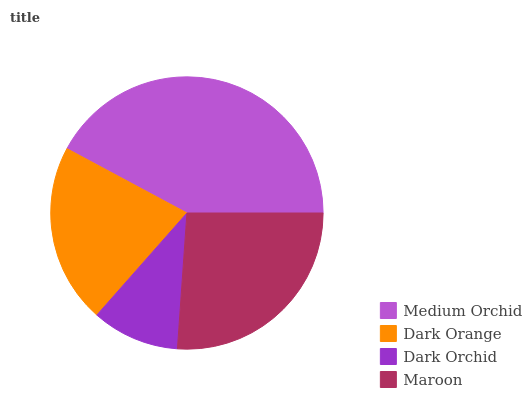Is Dark Orchid the minimum?
Answer yes or no. Yes. Is Medium Orchid the maximum?
Answer yes or no. Yes. Is Dark Orange the minimum?
Answer yes or no. No. Is Dark Orange the maximum?
Answer yes or no. No. Is Medium Orchid greater than Dark Orange?
Answer yes or no. Yes. Is Dark Orange less than Medium Orchid?
Answer yes or no. Yes. Is Dark Orange greater than Medium Orchid?
Answer yes or no. No. Is Medium Orchid less than Dark Orange?
Answer yes or no. No. Is Maroon the high median?
Answer yes or no. Yes. Is Dark Orange the low median?
Answer yes or no. Yes. Is Dark Orchid the high median?
Answer yes or no. No. Is Medium Orchid the low median?
Answer yes or no. No. 